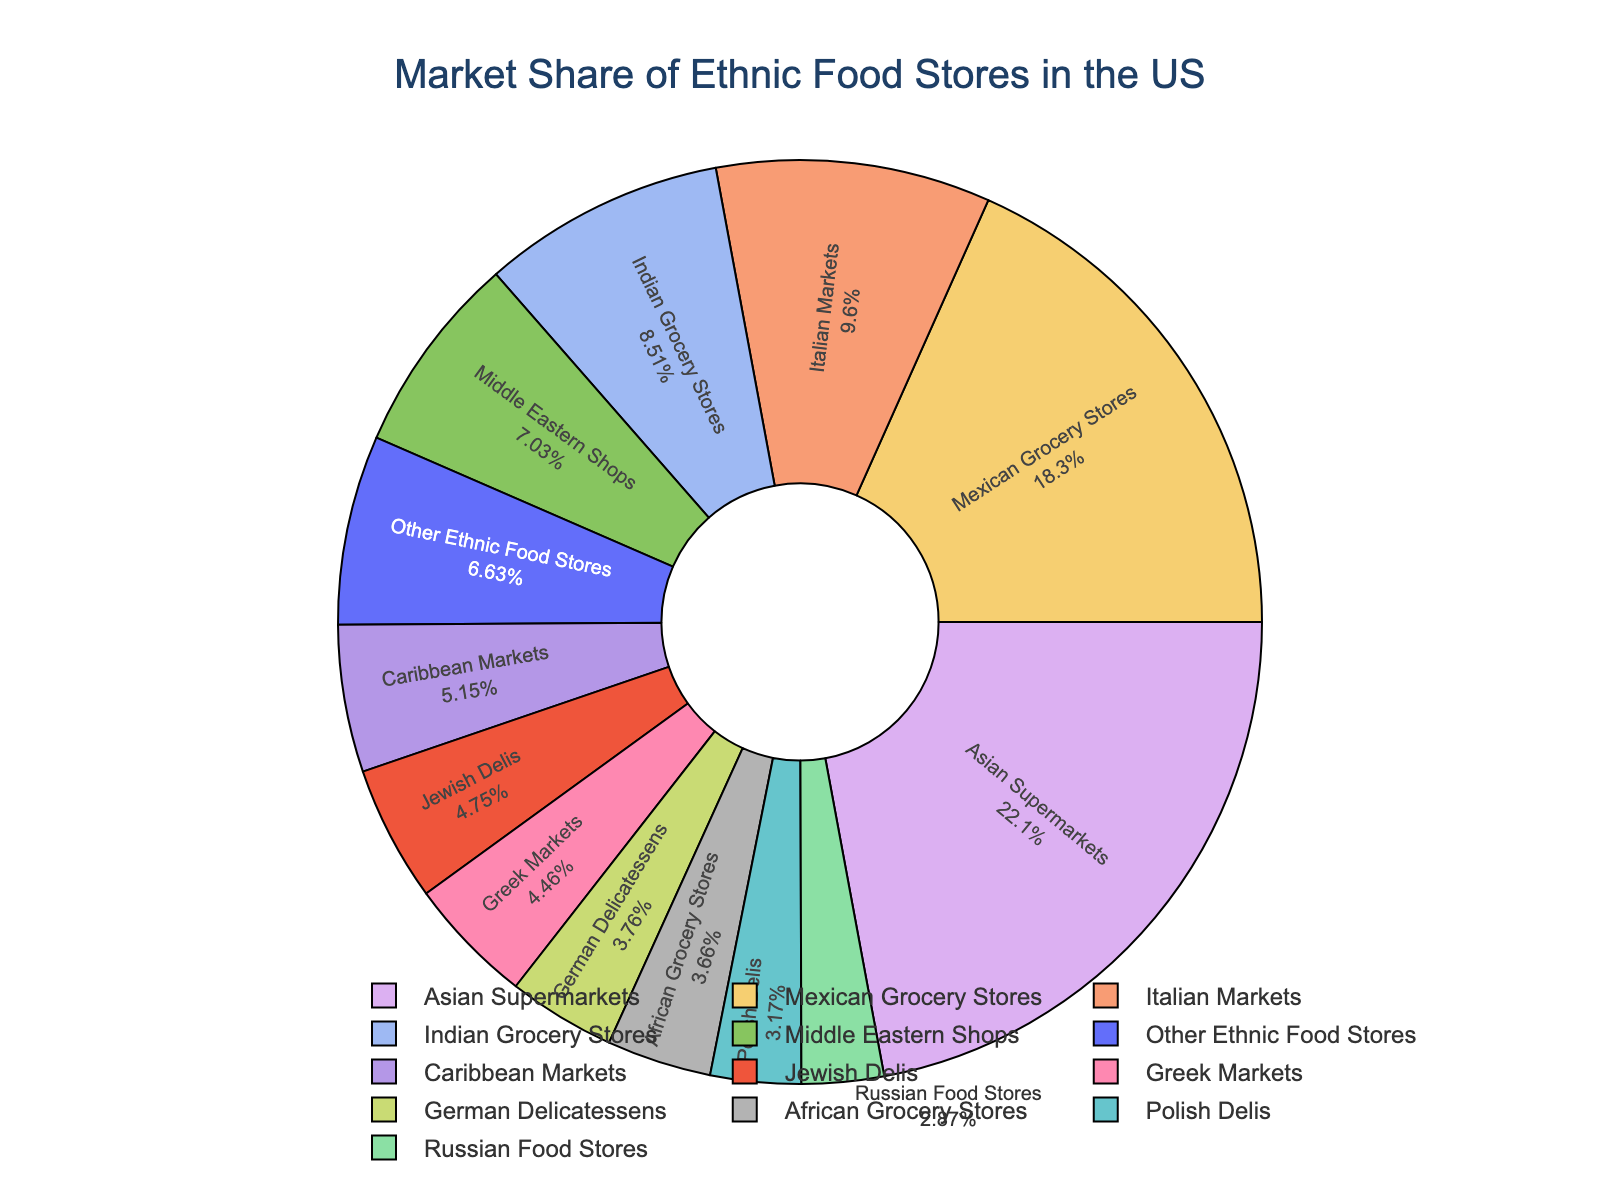Which category has the largest market share? By examining the pie chart, we see that the largest segment belongs to Asian Supermarkets.
Answer: Asian Supermarkets Which categories have a market share greater than 10%? The pie chart shows the market shares, and we identify the segments representing Asian Supermarkets (22.3%), Mexican Grocery Stores (18.5%), and Italian Markets (9.7%). Checking, only Asian Supermarkets and Mexican Grocery Stores are above 10%.
Answer: Asian Supermarkets, Mexican Grocery Stores What is the combined market share of Polish Delis and German Delicatessens? Polish Delis have a market share of 3.2%, and German Delicatessens have 3.8%. Combining them results in 3.2% + 3.8% = 7%.
Answer: 7% How much larger is the market share of Asian Supermarkets compared to Polish Delis? Asian Supermarkets have a market share of 22.3%, and Polish Delis have 3.2%. The difference is 22.3% - 3.2% = 19.1%.
Answer: 19.1% Which category has a market share closest to 5%? By checking the pie chart, Caribbean Markets have a market share of 5.2%, which is the closest to 5%.
Answer: Caribbean Markets What is the total market share of Indian, Greek, and Jewish food stores? Indian Grocery Stores have an 8.6% share, Greek Markets 4.5%, and Jewish Delis 4.8%. Summing these up: 8.6% + 4.5% + 4.8% = 17.9%.
Answer: 17.9% Which has a larger market share: African Grocery Stores or German Delicatessens? African Grocery Stores have a 3.7% market share, while German Delicatessens have 3.8%. German Delicatessens have a slightly larger share.
Answer: German Delicatessens How many categories have a market share less than 5%? By counting the segments on the pie chart with less than 5%: Polish Delis (3.2%), German Delicatessens (3.8%), Russian Food Stores (2.9%), African Grocery Stores (3.7%). That's four categories.
Answer: 4 categories What is the market share difference between the second and third largest categories? The second-largest category is Mexican Grocery Stores (18.5%) and the third largest is Italian Markets (9.7%). The difference is 18.5% - 9.7% = 8.8%.
Answer: 8.8% 